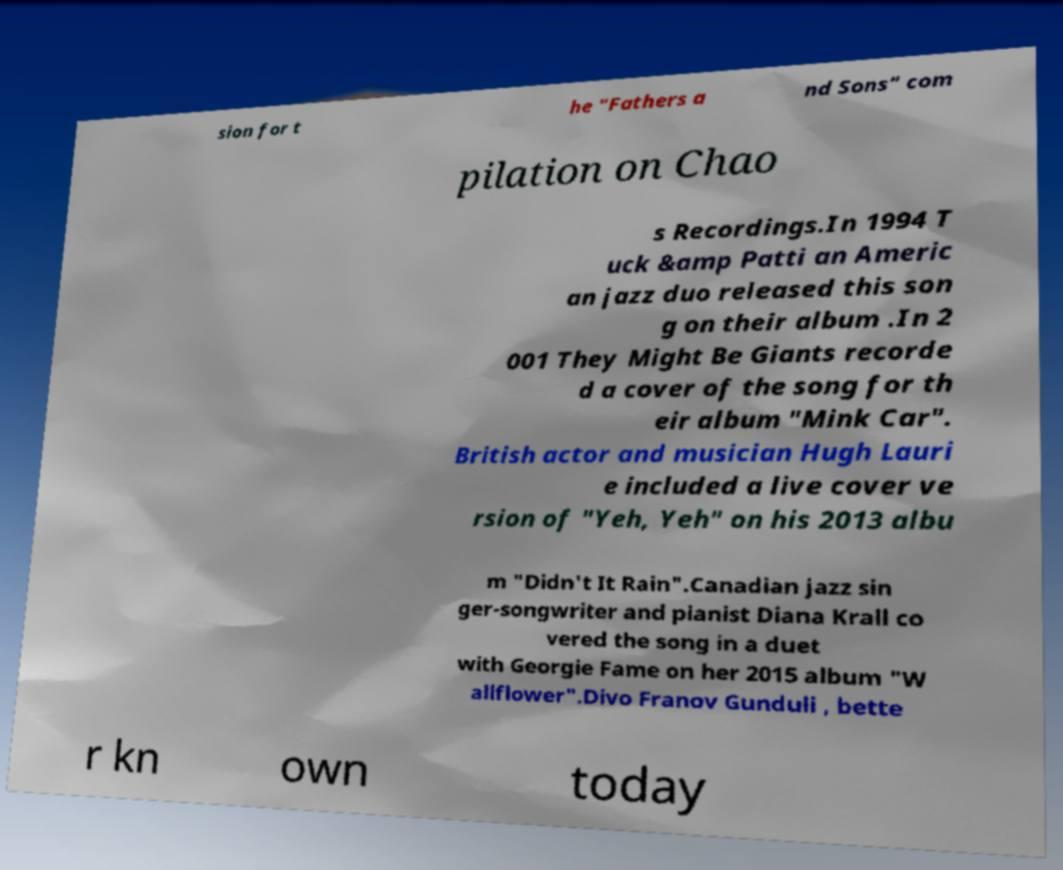Please read and relay the text visible in this image. What does it say? sion for t he "Fathers a nd Sons" com pilation on Chao s Recordings.In 1994 T uck &amp Patti an Americ an jazz duo released this son g on their album .In 2 001 They Might Be Giants recorde d a cover of the song for th eir album "Mink Car". British actor and musician Hugh Lauri e included a live cover ve rsion of "Yeh, Yeh" on his 2013 albu m "Didn't It Rain".Canadian jazz sin ger-songwriter and pianist Diana Krall co vered the song in a duet with Georgie Fame on her 2015 album "W allflower".Divo Franov Gunduli , bette r kn own today 